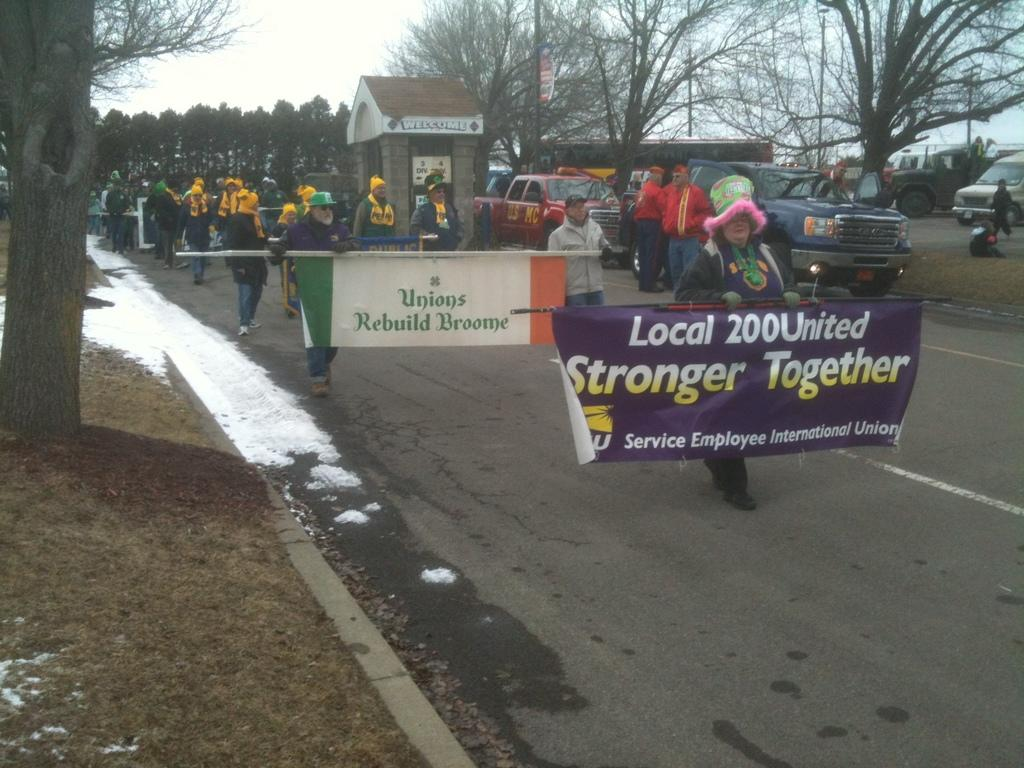What are the people in the image doing? The people in the image are walking on a road. What are some of the people holding? Some people are holding banners. What can be read on the banners? There is text on the banners. What else can be seen on the road? There are cars visible in the image. What is visible in the background of the image? There are trees and a small house in the background of the image. Can you see a snake slithering across the road in the image? No, there is no snake present in the image. What type of bird is perched on the small house in the background? There is no bird visible on the small house in the background of the image. 